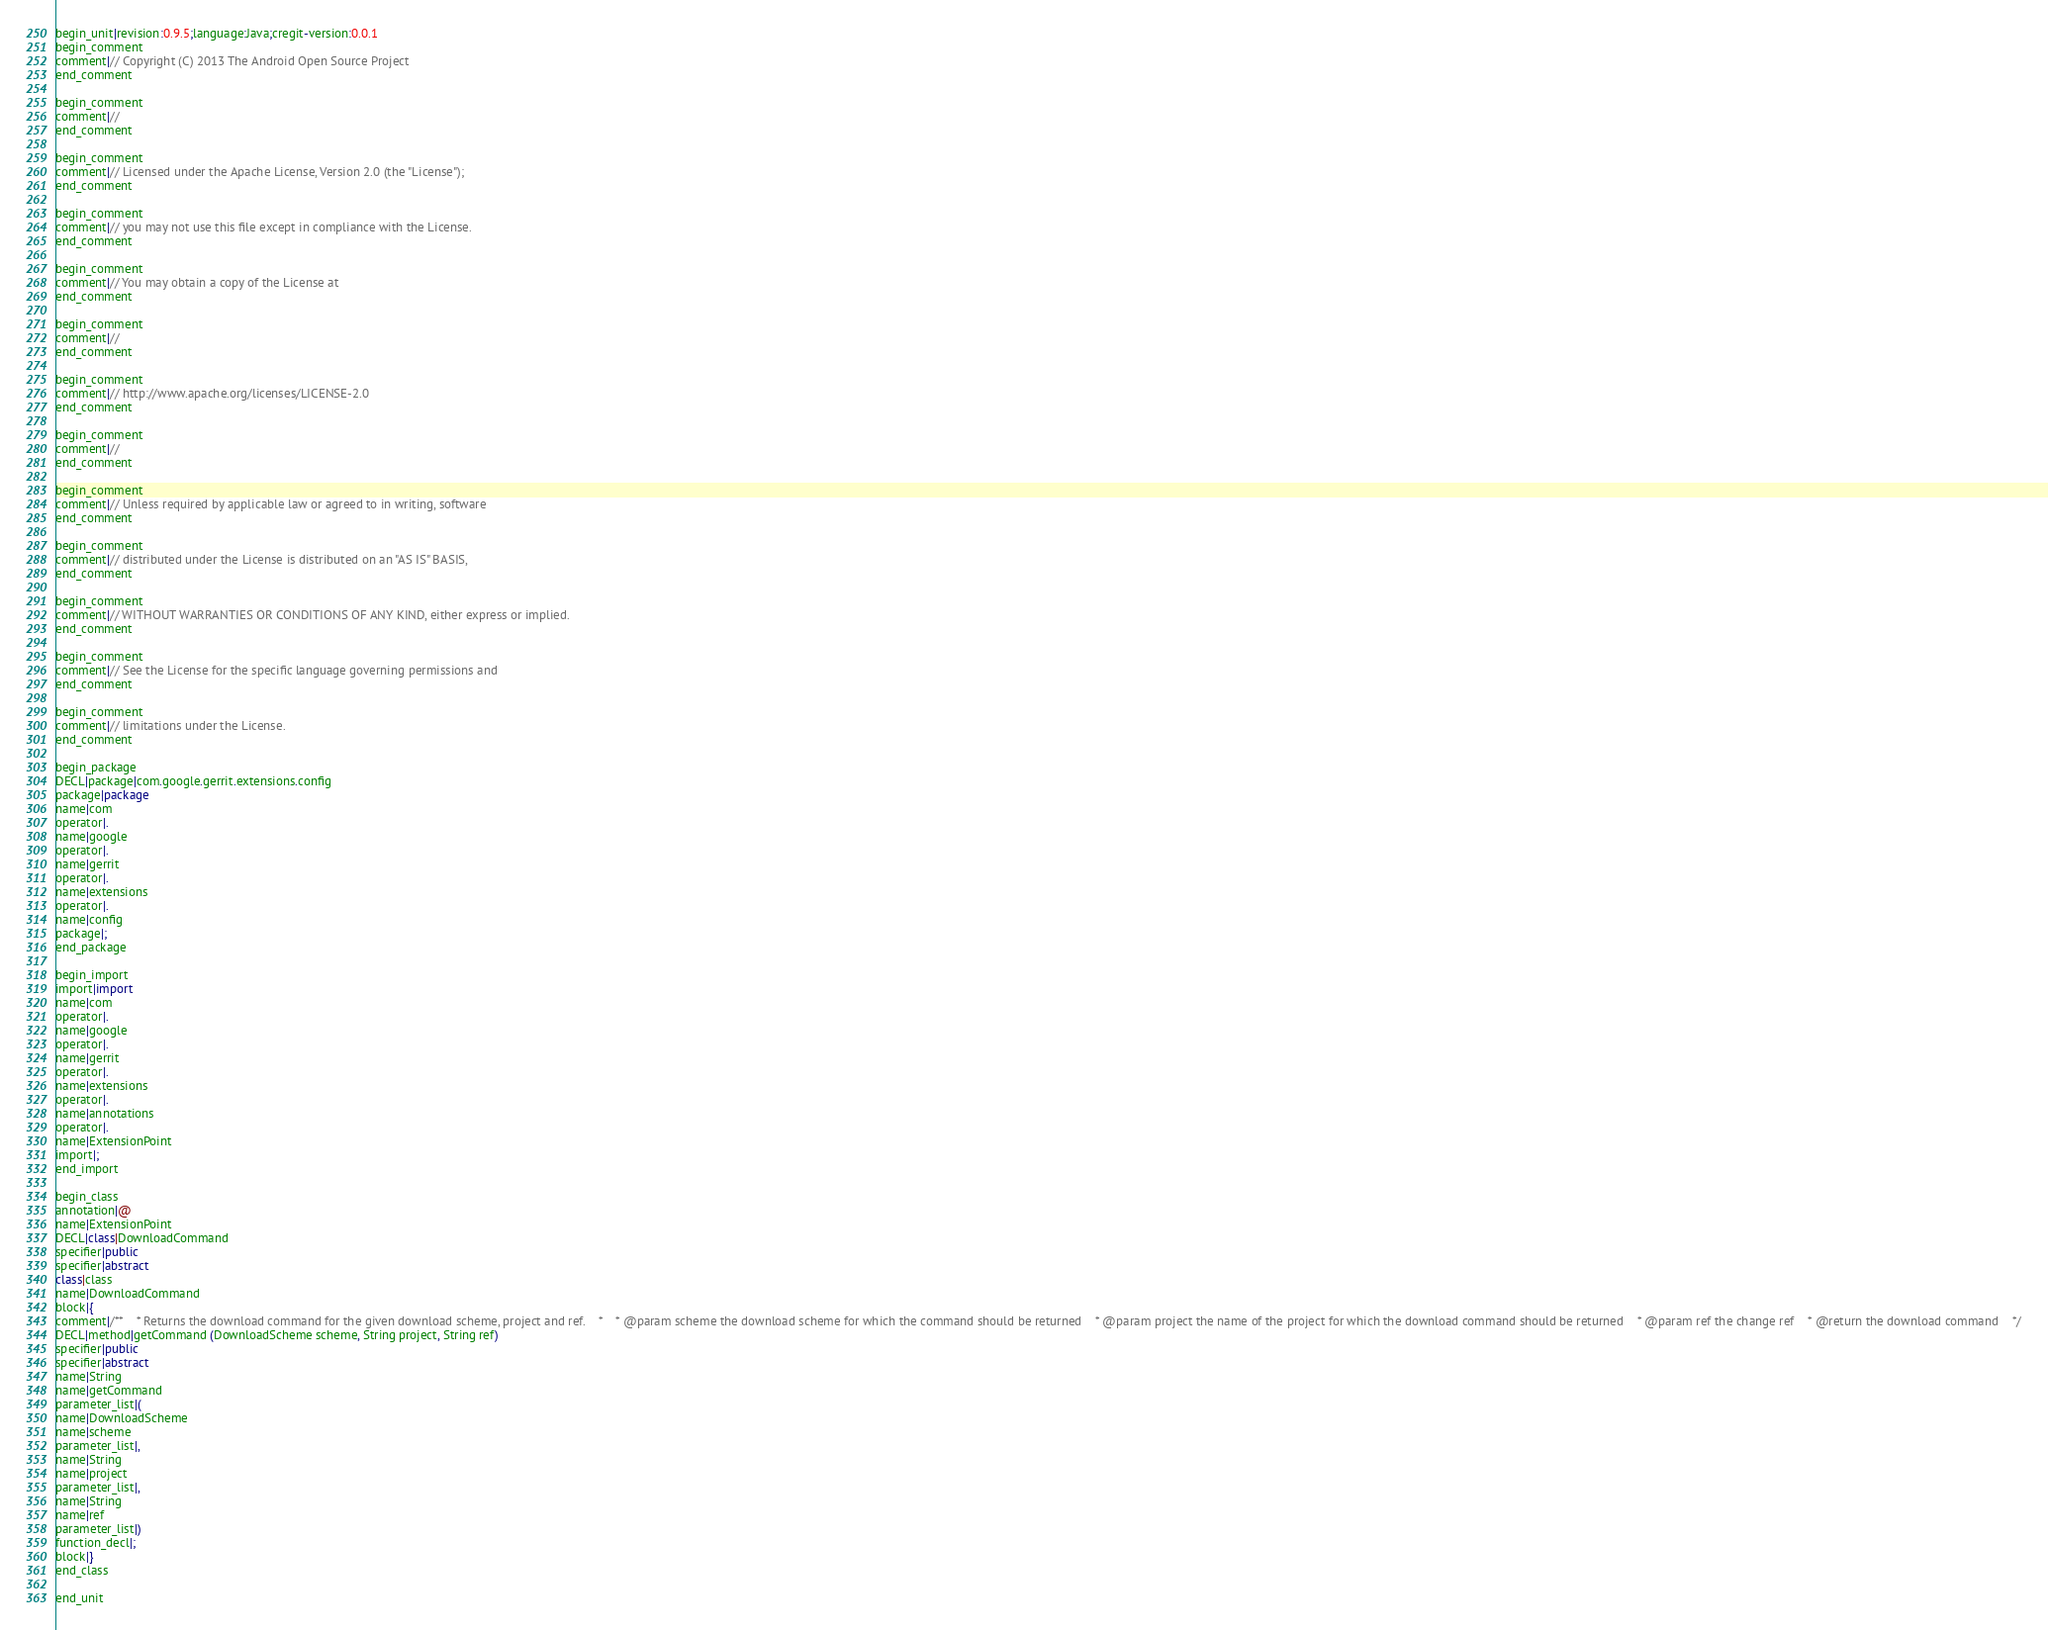<code> <loc_0><loc_0><loc_500><loc_500><_Java_>begin_unit|revision:0.9.5;language:Java;cregit-version:0.0.1
begin_comment
comment|// Copyright (C) 2013 The Android Open Source Project
end_comment

begin_comment
comment|//
end_comment

begin_comment
comment|// Licensed under the Apache License, Version 2.0 (the "License");
end_comment

begin_comment
comment|// you may not use this file except in compliance with the License.
end_comment

begin_comment
comment|// You may obtain a copy of the License at
end_comment

begin_comment
comment|//
end_comment

begin_comment
comment|// http://www.apache.org/licenses/LICENSE-2.0
end_comment

begin_comment
comment|//
end_comment

begin_comment
comment|// Unless required by applicable law or agreed to in writing, software
end_comment

begin_comment
comment|// distributed under the License is distributed on an "AS IS" BASIS,
end_comment

begin_comment
comment|// WITHOUT WARRANTIES OR CONDITIONS OF ANY KIND, either express or implied.
end_comment

begin_comment
comment|// See the License for the specific language governing permissions and
end_comment

begin_comment
comment|// limitations under the License.
end_comment

begin_package
DECL|package|com.google.gerrit.extensions.config
package|package
name|com
operator|.
name|google
operator|.
name|gerrit
operator|.
name|extensions
operator|.
name|config
package|;
end_package

begin_import
import|import
name|com
operator|.
name|google
operator|.
name|gerrit
operator|.
name|extensions
operator|.
name|annotations
operator|.
name|ExtensionPoint
import|;
end_import

begin_class
annotation|@
name|ExtensionPoint
DECL|class|DownloadCommand
specifier|public
specifier|abstract
class|class
name|DownloadCommand
block|{
comment|/**    * Returns the download command for the given download scheme, project and ref.    *    * @param scheme the download scheme for which the command should be returned    * @param project the name of the project for which the download command should be returned    * @param ref the change ref    * @return the download command    */
DECL|method|getCommand (DownloadScheme scheme, String project, String ref)
specifier|public
specifier|abstract
name|String
name|getCommand
parameter_list|(
name|DownloadScheme
name|scheme
parameter_list|,
name|String
name|project
parameter_list|,
name|String
name|ref
parameter_list|)
function_decl|;
block|}
end_class

end_unit

</code> 